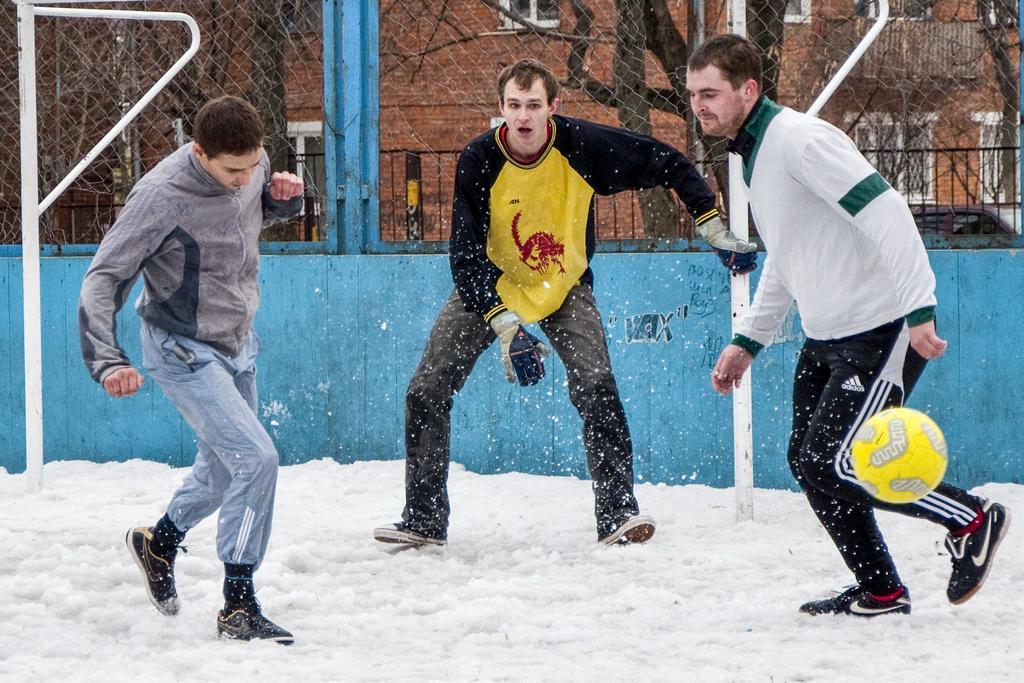How would you summarize this image in a sentence or two? At the bottom of this image I can see the snow. Here three men are playing with a ball. In the background there are two poles and a net fencing. Behind the net fencing there are many trees and a building. 